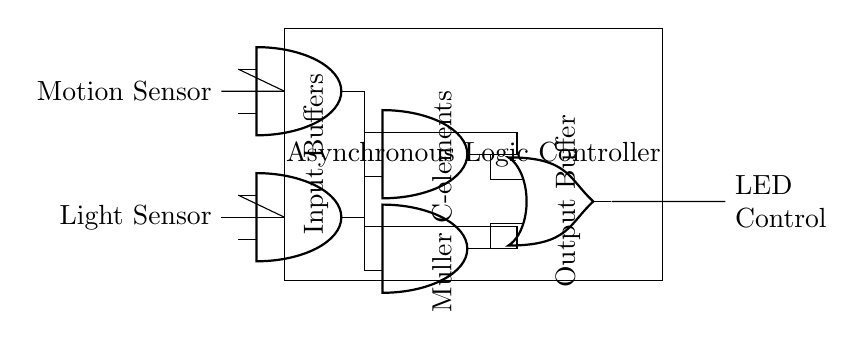what are the input sensors in the circuit? The input sensors identified in the circuit are the Light Sensor and the Motion Sensor. These are depicted at the left side of the diagram, indicating their role in detecting environmental conditions.
Answer: Light Sensor, Motion Sensor how many Muller C-elements are present in the circuit? The circuit contains two Muller C-elements, labeled in the diagram as two American AND ports positioned in the middle section. They are integral for asynchronous logic.
Answer: two what type of output does this circuit control? The output controlled by the circuit is for LED access, as noted on the right-hand side of the diagram where it states "LED Control." This refers to the intended action of the logic controller in response to sensor inputs.
Answer: LED Control describe the function of the input buffers in the circuit. The input buffers serve to process signals from the Light and Motion Sensors before they are fed into the asynchronous logic controller. Their purpose is to ensure that the signals are appropriately conditioned for further processing.
Answer: signal conditioning what role do feedback loops play in the Muller C-elements? Feedback loops in Muller C-elements allow for stable states by enabling them to remember input values. This is critical in asynchronous logic circuits to maintain consistent outputs despite variable input conditions.
Answer: stability and memory how many output connections are there from the asynchronous logic controller? There is one output connection from the asynchronous logic controller that leads to the LED control. This is represented in the circuit as a single line extending from the output buffer.
Answer: one 